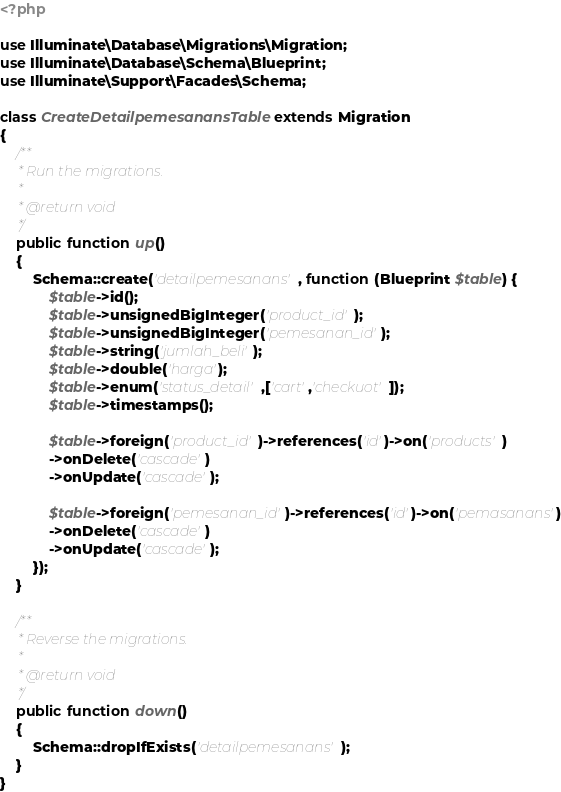Convert code to text. <code><loc_0><loc_0><loc_500><loc_500><_PHP_><?php

use Illuminate\Database\Migrations\Migration;
use Illuminate\Database\Schema\Blueprint;
use Illuminate\Support\Facades\Schema;

class CreateDetailpemesanansTable extends Migration
{
    /**
     * Run the migrations.
     *
     * @return void
     */
    public function up()
    {
        Schema::create('detailpemesanans', function (Blueprint $table) {
            $table->id();
            $table->unsignedBigInteger('product_id');
            $table->unsignedBigInteger('pemesanan_id');
            $table->string('jumlah_beli');
            $table->double('harga');
            $table->enum('status_detail',['cart','checkuot']);
            $table->timestamps();

            $table->foreign('product_id')->references('id')->on('products')
            ->onDelete('cascade')
            ->onUpdate('cascade');

            $table->foreign('pemesanan_id')->references('id')->on('pemasanans')
            ->onDelete('cascade')
            ->onUpdate('cascade');
        });
    }

    /**
     * Reverse the migrations.
     *
     * @return void
     */
    public function down()
    {
        Schema::dropIfExists('detailpemesanans');
    }
}
</code> 